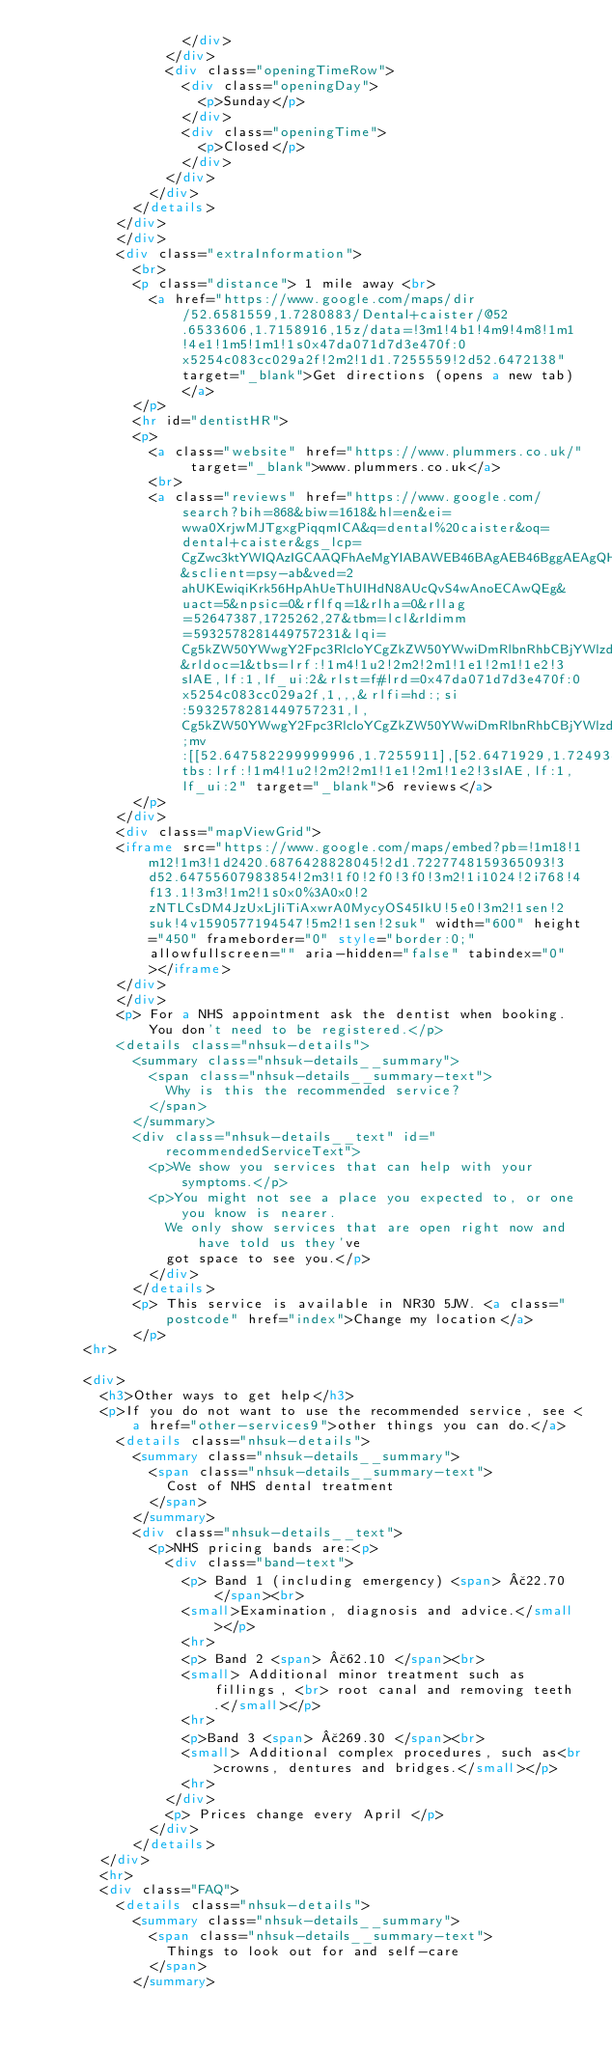Convert code to text. <code><loc_0><loc_0><loc_500><loc_500><_HTML_>                  </div>
                </div>
                <div class="openingTimeRow">
                  <div class="openingDay">
                    <p>Sunday</p>
                  </div>
                  <div class="openingTime">
                    <p>Closed</p>
                  </div>
                </div>
              </div>
            </details>
          </div>
          </div>
          <div class="extraInformation">
            <br>
            <p class="distance"> 1 mile away <br>
              <a href="https://www.google.com/maps/dir/52.6581559,1.7280883/Dental+caister/@52.6533606,1.7158916,15z/data=!3m1!4b1!4m9!4m8!1m1!4e1!1m5!1m1!1s0x47da071d7d3e470f:0x5254c083cc029a2f!2m2!1d1.7255559!2d52.6472138" target="_blank">Get directions (opens a new tab)</a>
            </p>
            <hr id="dentistHR">
            <p>
              <a class="website" href="https://www.plummers.co.uk/" target="_blank">www.plummers.co.uk</a>
              <br>
              <a class="reviews" href="https://www.google.com/search?bih=868&biw=1618&hl=en&ei=wwa0XrjwMJTgxgPiqqmICA&q=dental%20caister&oq=dental+caister&gs_lcp=CgZwc3ktYWIQAzIGCAAQFhAeMgYIABAWEB46BAgAEB46BggAEAgQHjoECAAQDToGCAAQDRAeOggIABANEAUQHjoICAAQCBANEB46AggAOgQIABAKOggIABCRAhCLAzoICAAQgwEQiwM6BQgAEIsDOgUIABCDAToICAAQFhAKEB5QhRhYoyVgjyZoAHAAeACAAXqIAeMIkgEEMTMuMZgBAKABAaoBB2d3cy13aXq4AQI&sclient=psy-ab&ved=2ahUKEwiqiKrk56HpAhUeThUIHdN8AUcQvS4wAnoECAwQEg&uact=5&npsic=0&rflfq=1&rlha=0&rllag=52647387,1725262,27&tbm=lcl&rldimm=5932578281449757231&lqi=Cg5kZW50YWwgY2Fpc3RlcloYCgZkZW50YWwiDmRlbnRhbCBjYWlzdGVy&rldoc=1&tbs=lrf:!1m4!1u2!2m2!2m1!1e1!2m1!1e2!3sIAE,lf:1,lf_ui:2&rlst=f#lrd=0x47da071d7d3e470f:0x5254c083cc029a2f,1,,,&rlfi=hd:;si:5932578281449757231,l,Cg5kZW50YWwgY2Fpc3RlcloYCgZkZW50YWwiDmRlbnRhbCBjYWlzdGVy;mv:[[52.647582299999996,1.7255911],[52.6471929,1.7249343]];tbs:lrf:!1m4!1u2!2m2!2m1!1e1!2m1!1e2!3sIAE,lf:1,lf_ui:2" target="_blank">6 reviews</a>
            </p>
          </div>
          <div class="mapViewGrid">
          <iframe src="https://www.google.com/maps/embed?pb=!1m18!1m12!1m3!1d2420.6876428828045!2d1.7227748159365093!3d52.64755607983854!2m3!1f0!2f0!3f0!3m2!1i1024!2i768!4f13.1!3m3!1m2!1s0x0%3A0x0!2zNTLCsDM4JzUxLjIiTiAxwrA0MycyOS45IkU!5e0!3m2!1sen!2suk!4v1590577194547!5m2!1sen!2suk" width="600" height="450" frameborder="0" style="border:0;" allowfullscreen="" aria-hidden="false" tabindex="0"></iframe>
          </div>
          </div>
          <p> For a NHS appointment ask the dentist when booking. You don't need to be registered.</p>
          <details class="nhsuk-details">
            <summary class="nhsuk-details__summary">
              <span class="nhsuk-details__summary-text">
                Why is this the recommended service?
              </span>
            </summary>
            <div class="nhsuk-details__text" id="recommendedServiceText">
              <p>We show you services that can help with your symptoms.</p>
              <p>You might not see a place you expected to, or one you know is nearer.
                We only show services that are open right now and have told us they've
                got space to see you.</p>
              </div>
            </details>
            <p> This service is available in NR30 5JW. <a class="postcode" href="index">Change my location</a>
            </p>
      <hr>

      <div>
        <h3>Other ways to get help</h3>
        <p>If you do not want to use the recommended service, see <a href="other-services9">other things you can do.</a>
          <details class="nhsuk-details">
            <summary class="nhsuk-details__summary">
              <span class="nhsuk-details__summary-text">
                Cost of NHS dental treatment
              </span>
            </summary>
            <div class="nhsuk-details__text">
              <p>NHS pricing bands are:<p>
                <div class="band-text">
                  <p> Band 1 (including emergency) <span> £22.70 </span><br>
                  <small>Examination, diagnosis and advice.</small></p>
                  <hr>
                  <p> Band 2 <span> £62.10 </span><br>
                  <small> Additional minor treatment such as fillings, <br> root canal and removing teeth.</small></p>
                  <hr>
                  <p>Band 3 <span> £269.30 </span><br>
                  <small> Additional complex procedures, such as<br>crowns, dentures and bridges.</small></p>
                  <hr>
                </div>
                <p> Prices change every April </p>
              </div>
            </details>
        </div>
        <hr>
        <div class="FAQ">
          <details class="nhsuk-details">
            <summary class="nhsuk-details__summary">
              <span class="nhsuk-details__summary-text">
                Things to look out for and self-care
              </span>
            </summary></code> 